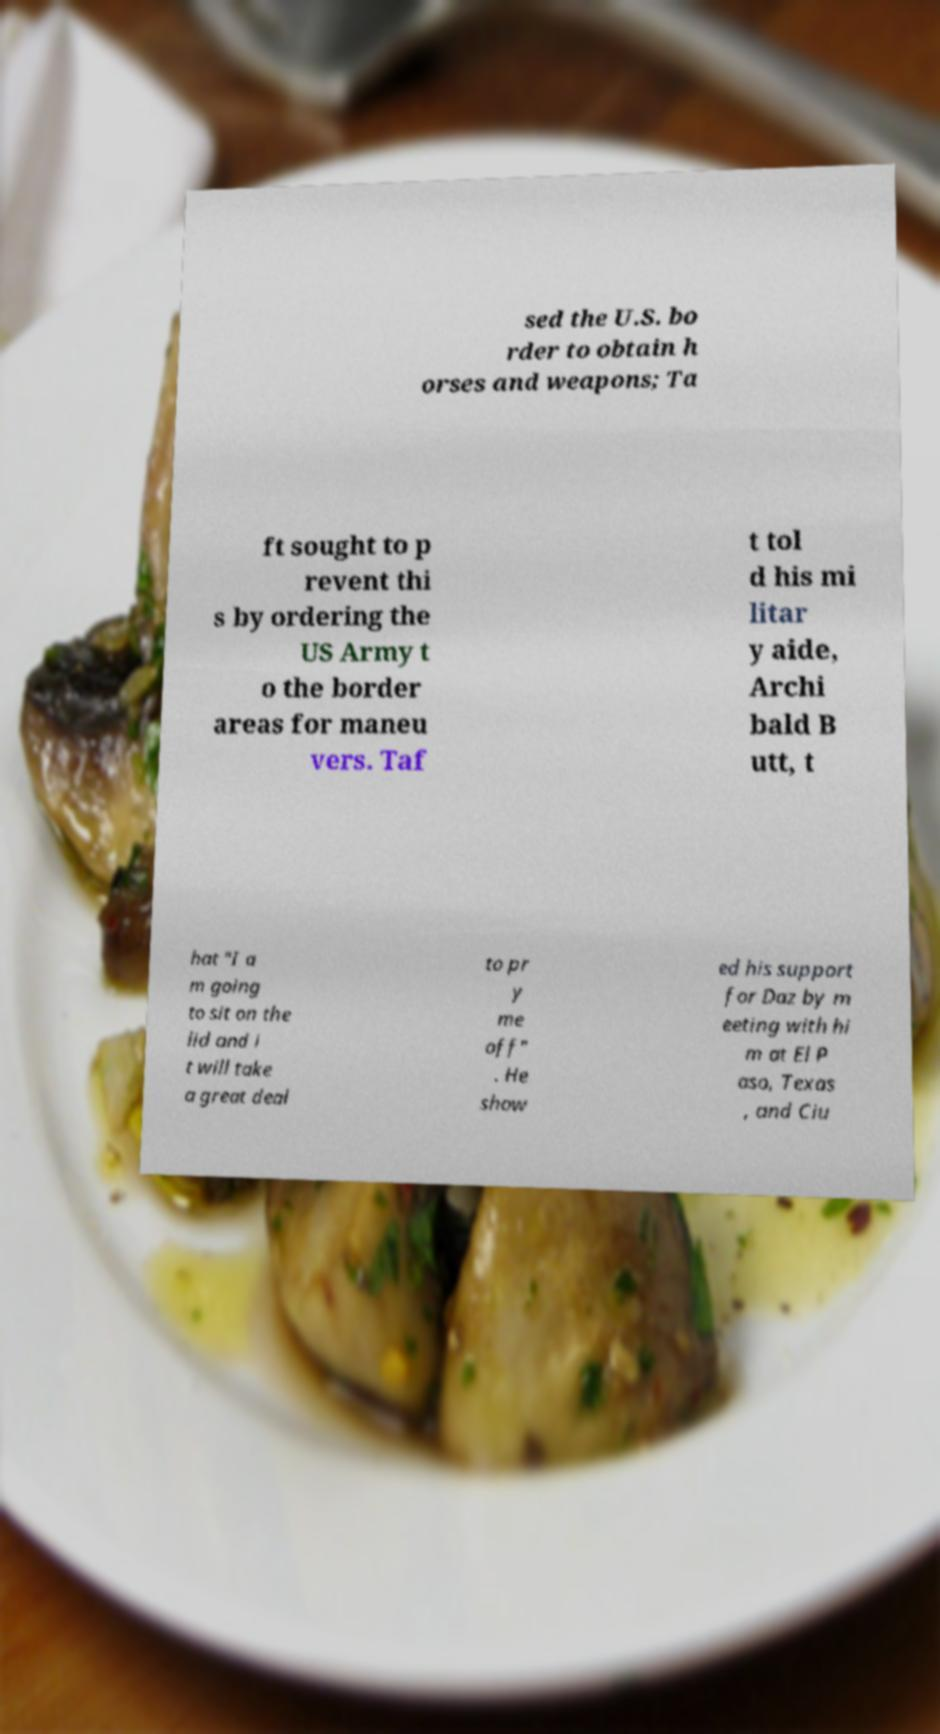Could you extract and type out the text from this image? sed the U.S. bo rder to obtain h orses and weapons; Ta ft sought to p revent thi s by ordering the US Army t o the border areas for maneu vers. Taf t tol d his mi litar y aide, Archi bald B utt, t hat "I a m going to sit on the lid and i t will take a great deal to pr y me off" . He show ed his support for Daz by m eeting with hi m at El P aso, Texas , and Ciu 